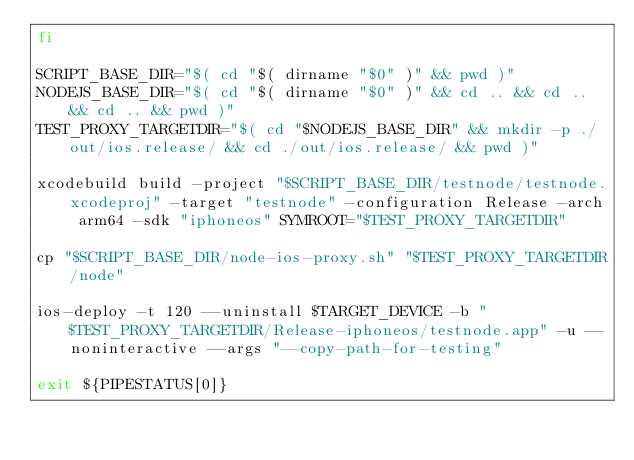<code> <loc_0><loc_0><loc_500><loc_500><_Bash_>fi

SCRIPT_BASE_DIR="$( cd "$( dirname "$0" )" && pwd )"
NODEJS_BASE_DIR="$( cd "$( dirname "$0" )" && cd .. && cd .. && cd .. && pwd )"
TEST_PROXY_TARGETDIR="$( cd "$NODEJS_BASE_DIR" && mkdir -p ./out/ios.release/ && cd ./out/ios.release/ && pwd )"

xcodebuild build -project "$SCRIPT_BASE_DIR/testnode/testnode.xcodeproj" -target "testnode" -configuration Release -arch arm64 -sdk "iphoneos" SYMROOT="$TEST_PROXY_TARGETDIR"

cp "$SCRIPT_BASE_DIR/node-ios-proxy.sh" "$TEST_PROXY_TARGETDIR/node"

ios-deploy -t 120 --uninstall $TARGET_DEVICE -b "$TEST_PROXY_TARGETDIR/Release-iphoneos/testnode.app" -u --noninteractive --args "--copy-path-for-testing"

exit ${PIPESTATUS[0]}
</code> 